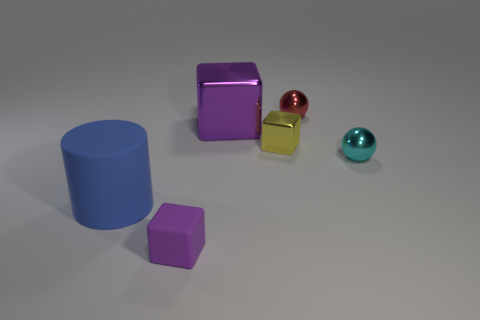Add 2 small purple metallic cylinders. How many objects exist? 8 Subtract all cylinders. How many objects are left? 5 Add 4 big blue objects. How many big blue objects are left? 5 Add 5 tiny yellow balls. How many tiny yellow balls exist? 5 Subtract 0 brown cubes. How many objects are left? 6 Subtract all tiny cyan metallic balls. Subtract all small objects. How many objects are left? 1 